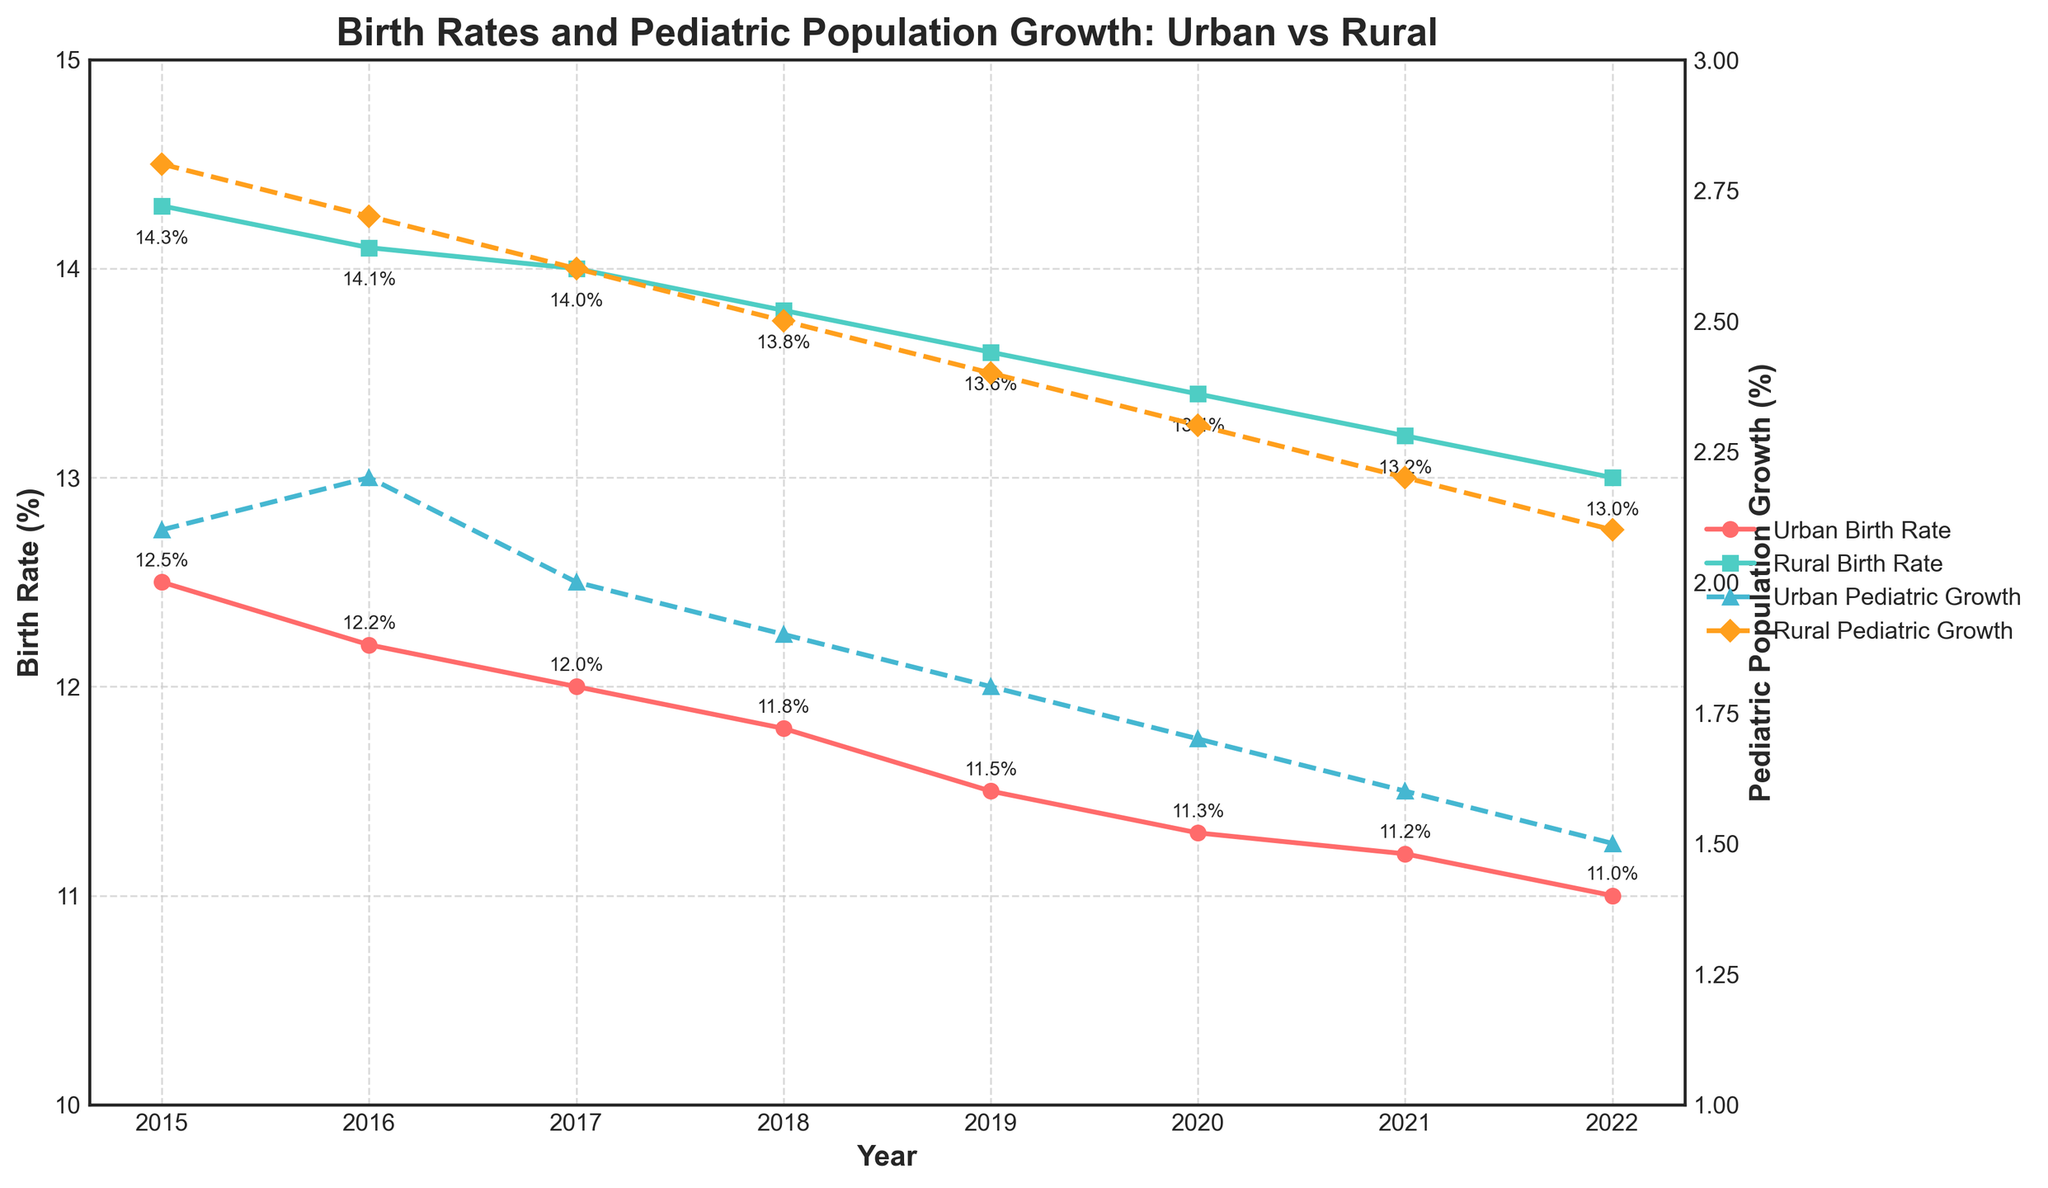What's the title of the figure? The title is usually located at the top of the figure, and it provides an overview of what the figure is about.
Answer: Birth Rates and Pediatric Population Growth: Urban vs Rural What are the colors used to represent the urban and rural birth rates? The urban birth rate line is red, and the rural birth rate line is turquoise. These colors help to differentiate between the two rates.
Answer: Red for urban, Turquoise for rural How have the urban and rural birth rates changed from 2015 to 2022? The urban birth rate declined from 12.5% in 2015 to 11.0% in 2022, and the rural birth rate declined from 14.3% in 2015 to 13.0% in 2022. This shows a steady decrease in birth rates in both areas over the years.
Answer: Both decreased What year had the smallest difference between urban and rural birth rates? To find the smallest difference, calculate the difference for each year. The smallest difference is in 2022, with a difference of 13.0% - 11.0% = 2%.
Answer: 2022 In which year was the urban pediatric population growth rate the highest? The urban pediatric population growth rate data line consists of '↑' markers. Look for the highest point on this line. The highest rate is in 2016 at 2.2%.
Answer: 2016 What was the percentage of rural pediatric population growth in 2019? The rural pediatric population growth percentage for each year is marked on the graph with '♦' markers. Look at the position above 2019 on this line: it reads 2.4%.
Answer: 2.4% How many percentage points did the rural pediatric population growth decrease from 2015 to 2022? Subtract the rural pediatric population growth in 2022 (2.1%) from that in 2015 (2.8%): 2.8% - 2.1% = 0.7%.
Answer: 0.7% Compare the trends of urban birth rates with urban pediatric population growth from 2015 to 2022. Both the urban birth rate and pediatric population growth show a decreasing trend from 2015 to 2022. This indicates a consistent decline in both birth rates and growth of the pediatric population in urban areas.
Answer: Both decreased Which area experienced a greater decline in birth rates from 2015 to 2022, urban or rural? Calculate the decline for both: Urban: 12.5% - 11.0% = 1.5%, Rural: 14.3% - 13.0% = 1.3%. The urban area experienced a greater decline (1.5%).
Answer: Urban What is the trend observed in pediatric population growth rates in rural areas from 2015 to 2022? The rural pediatric population growth rate has a steadily decreasing trend over the years, going from 2.8% in 2015 to 2.1% in 2022. This shows a consistent decline.
Answer: Decreasing trend 